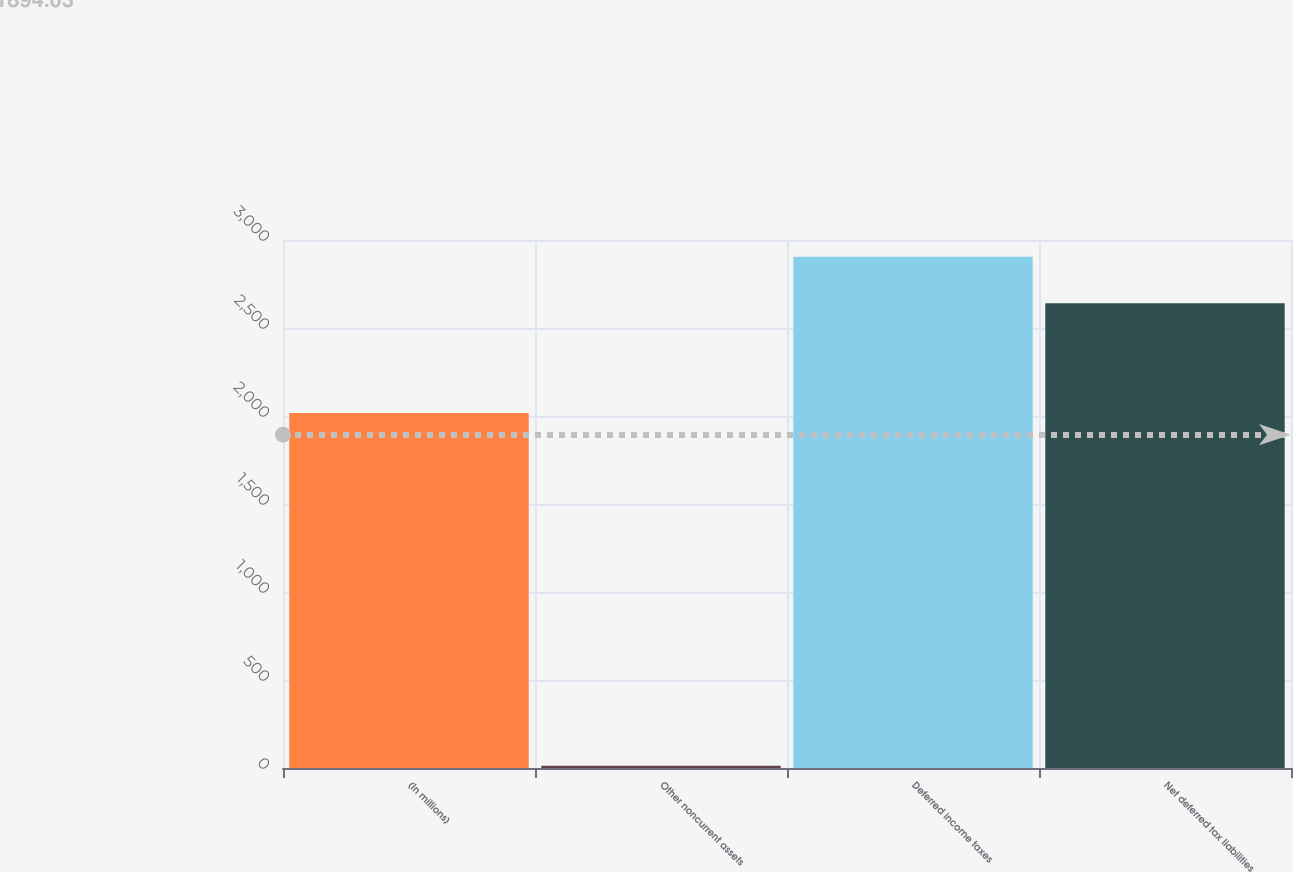Convert chart to OTSL. <chart><loc_0><loc_0><loc_500><loc_500><bar_chart><fcel>(In millions)<fcel>Other noncurrent assets<fcel>Deferred income taxes<fcel>Net deferred tax liabilities<nl><fcel>2017<fcel>13<fcel>2905.1<fcel>2641<nl></chart> 